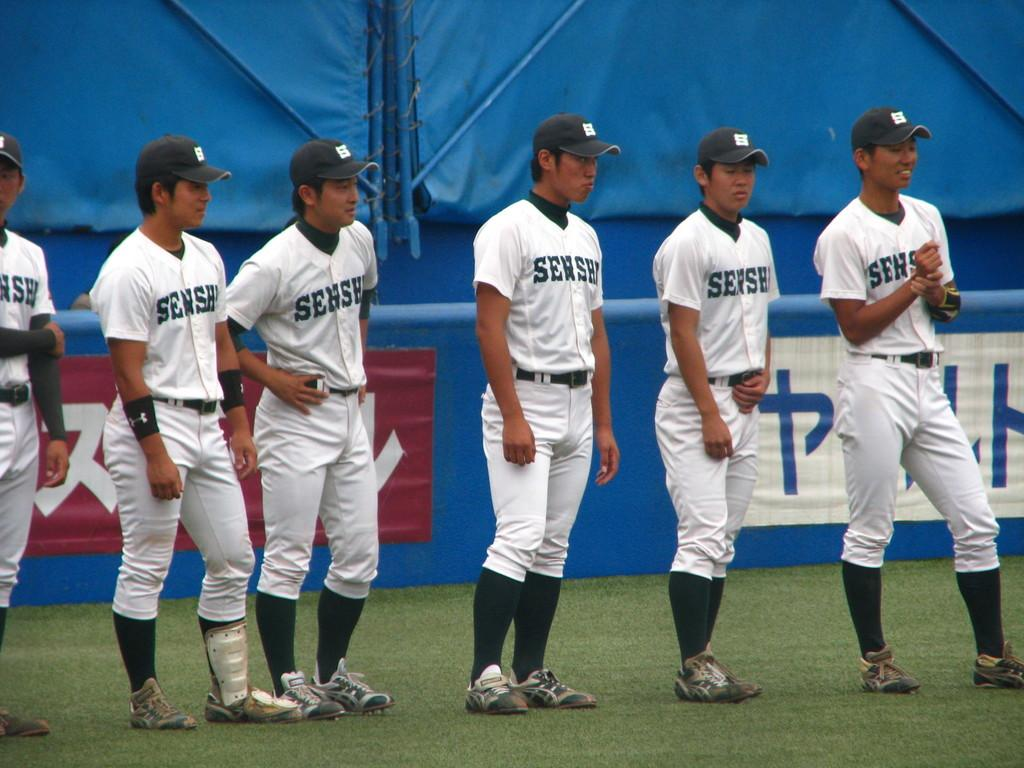<image>
Share a concise interpretation of the image provided. An Asian baseball team with shirts saying SENSE is lined up near the edge of the field. 